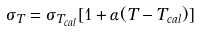<formula> <loc_0><loc_0><loc_500><loc_500>\sigma _ { T } = { \sigma _ { T _ { c a l } } [ 1 + \alpha ( T - T _ { c a l } ) ] }</formula> 